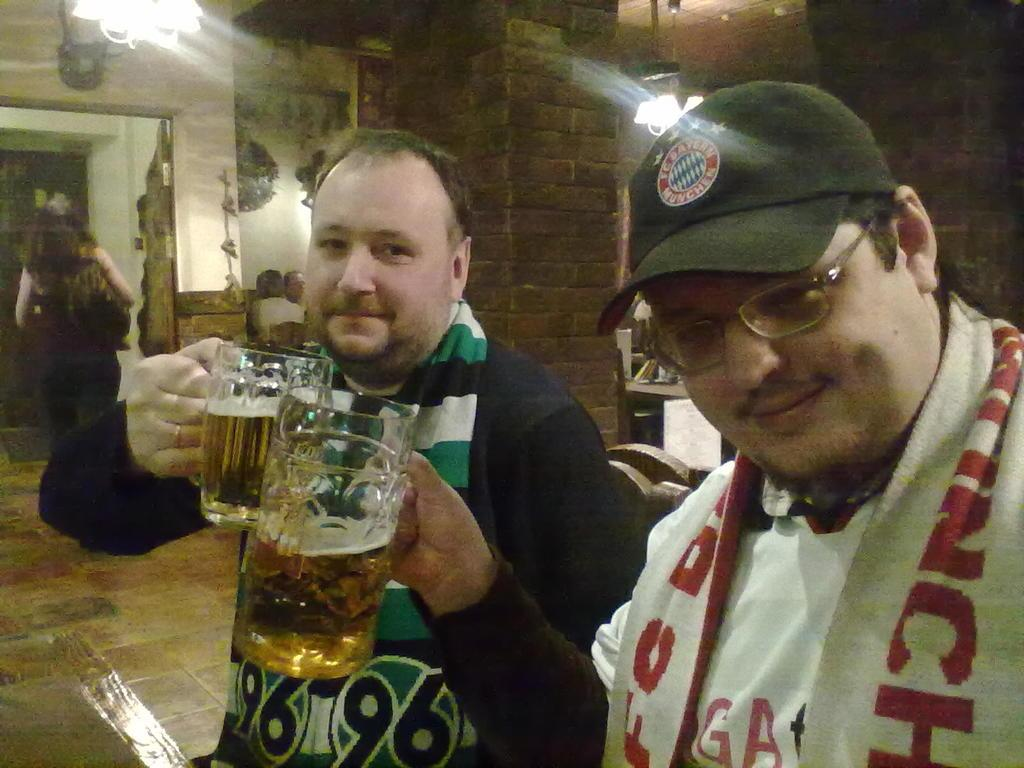How many people are in the image? There are three persons in the image. What are two of the persons holding? Two of the persons are holding glasses. What is the color of the wall in the image? There is a white color wall in the image. Can you describe the lighting in the image? Yes, there is light in the image. What type of educational treatment is being discussed by the persons in the image? There is no indication in the image that the persons are discussing any educational treatment or topic. 